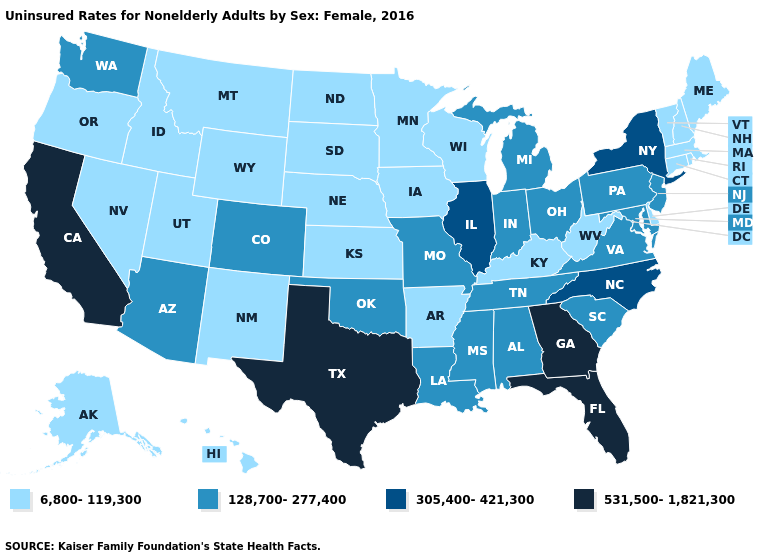Does New York have the highest value in the USA?
Short answer required. No. Name the states that have a value in the range 128,700-277,400?
Write a very short answer. Alabama, Arizona, Colorado, Indiana, Louisiana, Maryland, Michigan, Mississippi, Missouri, New Jersey, Ohio, Oklahoma, Pennsylvania, South Carolina, Tennessee, Virginia, Washington. What is the value of New York?
Answer briefly. 305,400-421,300. Does the first symbol in the legend represent the smallest category?
Quick response, please. Yes. Name the states that have a value in the range 305,400-421,300?
Keep it brief. Illinois, New York, North Carolina. What is the highest value in the USA?
Keep it brief. 531,500-1,821,300. Name the states that have a value in the range 128,700-277,400?
Be succinct. Alabama, Arizona, Colorado, Indiana, Louisiana, Maryland, Michigan, Mississippi, Missouri, New Jersey, Ohio, Oklahoma, Pennsylvania, South Carolina, Tennessee, Virginia, Washington. Name the states that have a value in the range 305,400-421,300?
Be succinct. Illinois, New York, North Carolina. Which states have the lowest value in the West?
Be succinct. Alaska, Hawaii, Idaho, Montana, Nevada, New Mexico, Oregon, Utah, Wyoming. Does Vermont have a higher value than Wyoming?
Short answer required. No. Does New Mexico have the highest value in the USA?
Give a very brief answer. No. Which states have the lowest value in the USA?
Be succinct. Alaska, Arkansas, Connecticut, Delaware, Hawaii, Idaho, Iowa, Kansas, Kentucky, Maine, Massachusetts, Minnesota, Montana, Nebraska, Nevada, New Hampshire, New Mexico, North Dakota, Oregon, Rhode Island, South Dakota, Utah, Vermont, West Virginia, Wisconsin, Wyoming. Name the states that have a value in the range 305,400-421,300?
Keep it brief. Illinois, New York, North Carolina. Does Alaska have the highest value in the West?
Short answer required. No. What is the highest value in the USA?
Quick response, please. 531,500-1,821,300. 